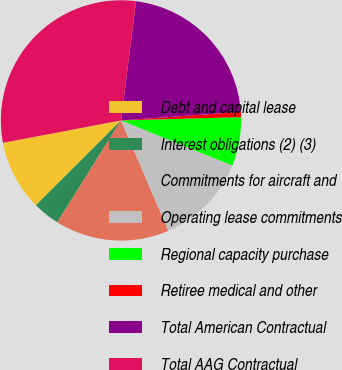<chart> <loc_0><loc_0><loc_500><loc_500><pie_chart><fcel>Debt and capital lease<fcel>Interest obligations (2) (3)<fcel>Commitments for aircraft and<fcel>Operating lease commitments<fcel>Regional capacity purchase<fcel>Retiree medical and other<fcel>Total American Contractual<fcel>Total AAG Contractual<nl><fcel>9.49%<fcel>3.63%<fcel>15.35%<fcel>12.42%<fcel>6.56%<fcel>0.7%<fcel>21.86%<fcel>30.0%<nl></chart> 